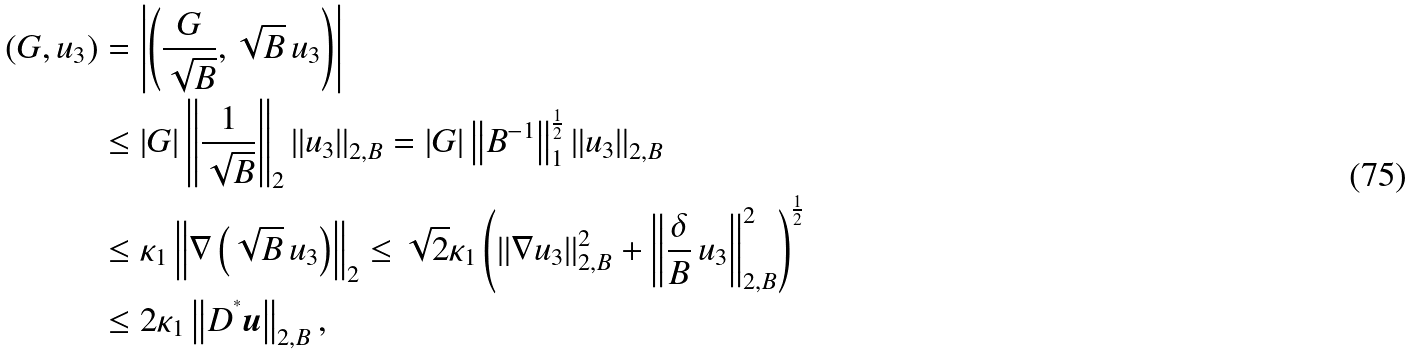Convert formula to latex. <formula><loc_0><loc_0><loc_500><loc_500>\left ( G , u _ { 3 } \right ) & = \left | \left ( \frac { G } { \sqrt { B } } , \sqrt { B } \, u _ { 3 } \right ) \right | \\ & \leq | G | \left \| \frac { 1 } { \sqrt { B } } \right \| _ { 2 } \left \| u _ { 3 } \right \| _ { 2 , B } = | G | \left \| B ^ { - 1 } \right \| _ { 1 } ^ { \frac { 1 } { 2 } } \left \| u _ { 3 } \right \| _ { 2 , B } \\ & \leq \kappa _ { 1 } \left \| \nabla \left ( \sqrt { B } \, u _ { 3 } \right ) \right \| _ { 2 } \leq \sqrt { 2 } \kappa _ { 1 } \left ( \left \| \nabla u _ { 3 } \right \| _ { 2 , B } ^ { 2 } + \left \| \frac { \delta } { B } \, u _ { 3 } \right \| _ { 2 , B } ^ { 2 } \right ) ^ { \frac { 1 } { 2 } } \\ & \leq 2 \kappa _ { 1 } \left \| D ^ { ^ { * } } { \boldsymbol u } \right \| _ { 2 , B } ,</formula> 